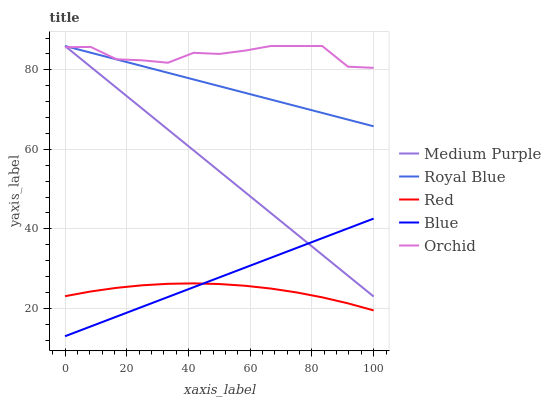Does Red have the minimum area under the curve?
Answer yes or no. Yes. Does Orchid have the maximum area under the curve?
Answer yes or no. Yes. Does Royal Blue have the minimum area under the curve?
Answer yes or no. No. Does Royal Blue have the maximum area under the curve?
Answer yes or no. No. Is Blue the smoothest?
Answer yes or no. Yes. Is Orchid the roughest?
Answer yes or no. Yes. Is Royal Blue the smoothest?
Answer yes or no. No. Is Royal Blue the roughest?
Answer yes or no. No. Does Blue have the lowest value?
Answer yes or no. Yes. Does Royal Blue have the lowest value?
Answer yes or no. No. Does Orchid have the highest value?
Answer yes or no. Yes. Does Red have the highest value?
Answer yes or no. No. Is Blue less than Orchid?
Answer yes or no. Yes. Is Royal Blue greater than Blue?
Answer yes or no. Yes. Does Blue intersect Medium Purple?
Answer yes or no. Yes. Is Blue less than Medium Purple?
Answer yes or no. No. Is Blue greater than Medium Purple?
Answer yes or no. No. Does Blue intersect Orchid?
Answer yes or no. No. 